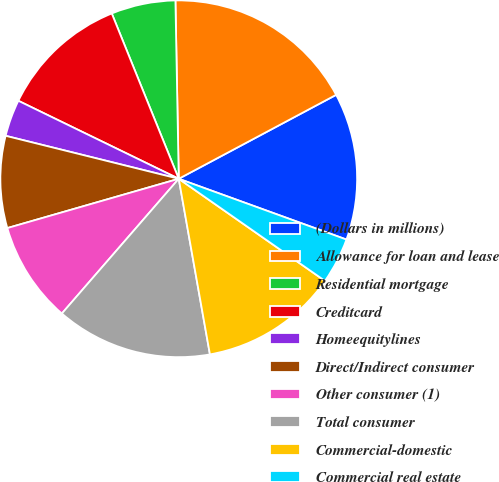<chart> <loc_0><loc_0><loc_500><loc_500><pie_chart><fcel>(Dollars in millions)<fcel>Allowance for loan and lease<fcel>Residential mortgage<fcel>Creditcard<fcel>Homeequitylines<fcel>Direct/Indirect consumer<fcel>Other consumer (1)<fcel>Total consumer<fcel>Commercial-domestic<fcel>Commercial real estate<nl><fcel>13.33%<fcel>17.5%<fcel>5.83%<fcel>11.67%<fcel>3.33%<fcel>8.33%<fcel>9.17%<fcel>14.17%<fcel>12.5%<fcel>4.17%<nl></chart> 